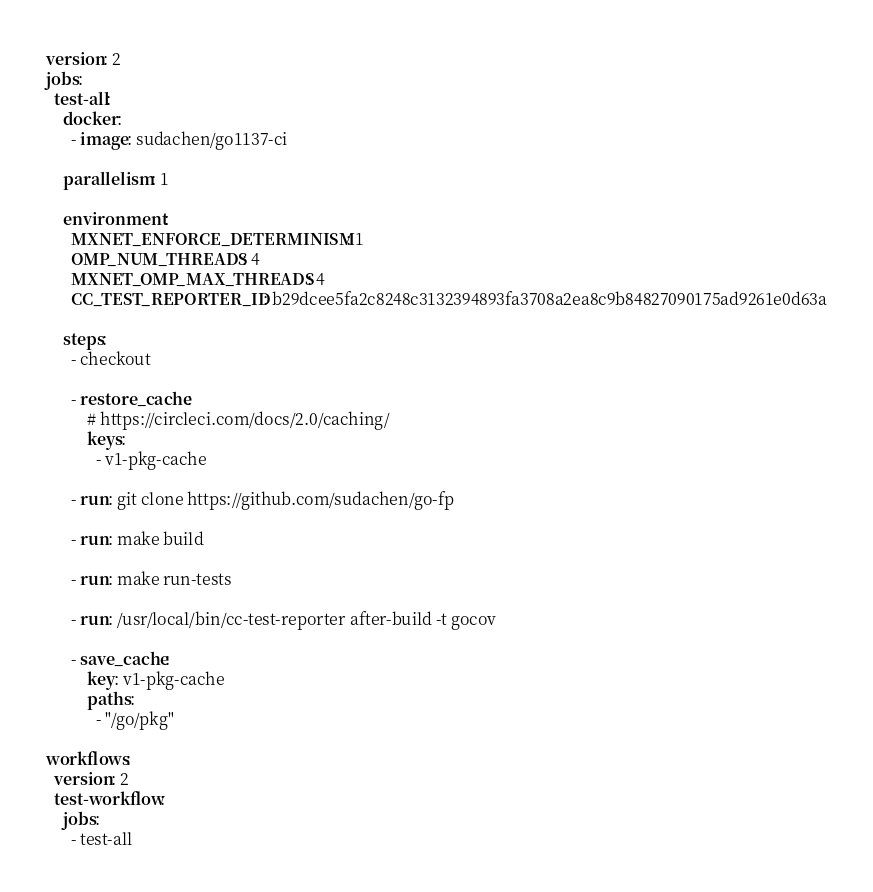Convert code to text. <code><loc_0><loc_0><loc_500><loc_500><_YAML_>version: 2
jobs:
  test-all:
    docker:
      - image: sudachen/go1137-ci

    parallelism: 1

    environment:
      MXNET_ENFORCE_DETERMINISM: 1
      OMP_NUM_THREADS: 4
      MXNET_OMP_MAX_THREADS: 4
      CC_TEST_REPORTER_ID: b29dcee5fa2c8248c3132394893fa3708a2ea8c9b84827090175ad9261e0d63a

    steps:
      - checkout

      - restore_cache:
          # https://circleci.com/docs/2.0/caching/
          keys:
            - v1-pkg-cache

      - run: git clone https://github.com/sudachen/go-fp

      - run: make build

      - run: make run-tests

      - run: /usr/local/bin/cc-test-reporter after-build -t gocov

      - save_cache:
          key: v1-pkg-cache
          paths:
            - "/go/pkg"

workflows:
  version: 2
  test-workflow:
    jobs:
      - test-all</code> 